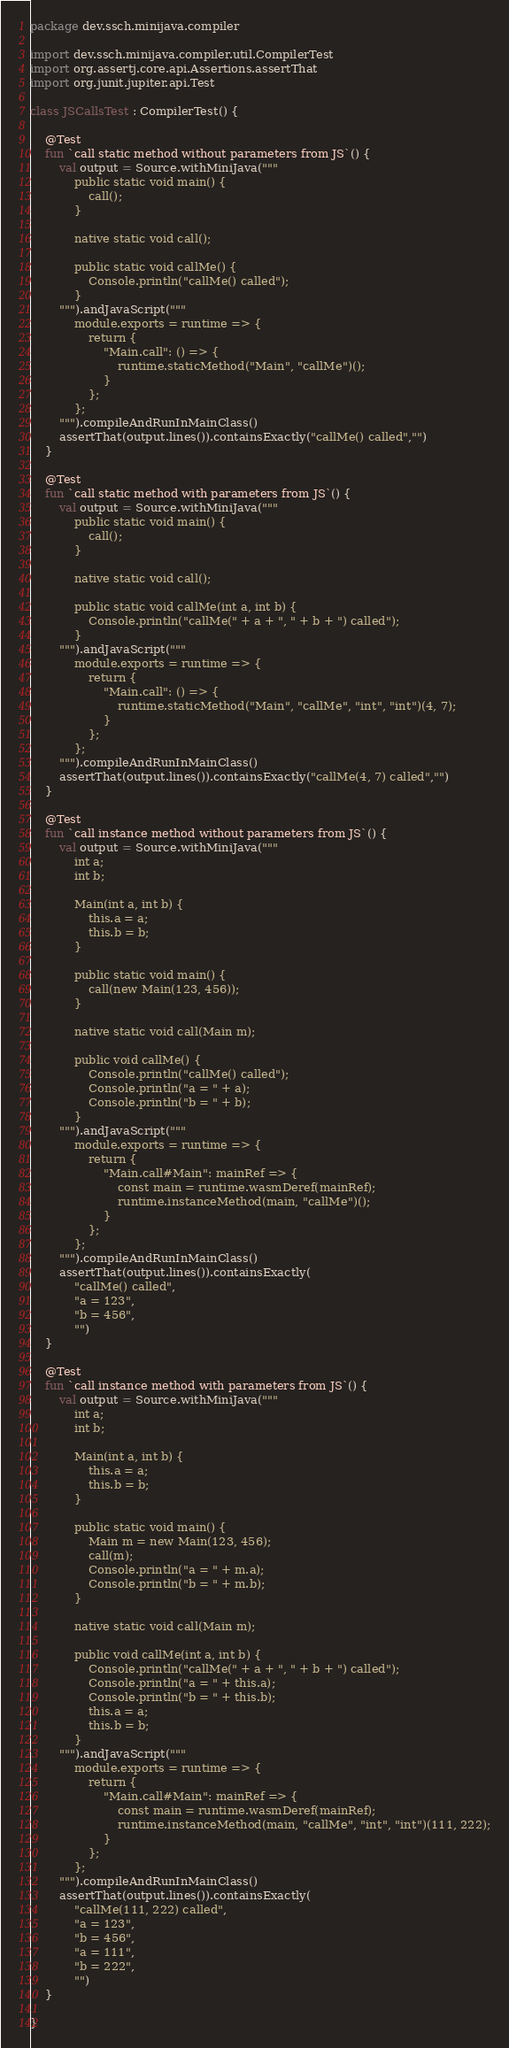<code> <loc_0><loc_0><loc_500><loc_500><_Kotlin_>package dev.ssch.minijava.compiler

import dev.ssch.minijava.compiler.util.CompilerTest
import org.assertj.core.api.Assertions.assertThat
import org.junit.jupiter.api.Test

class JSCallsTest : CompilerTest() {

    @Test
    fun `call static method without parameters from JS`() {
        val output = Source.withMiniJava("""
            public static void main() {
                call();
            }
            
            native static void call();
            
            public static void callMe() {
                Console.println("callMe() called");
            }
        """).andJavaScript("""
            module.exports = runtime => {
                return {
                    "Main.call": () => {
                        runtime.staticMethod("Main", "callMe")();
                    }
                };
            };
        """).compileAndRunInMainClass()
        assertThat(output.lines()).containsExactly("callMe() called","")
    }

    @Test
    fun `call static method with parameters from JS`() {
        val output = Source.withMiniJava("""
            public static void main() {
                call();
            }
            
            native static void call();
            
            public static void callMe(int a, int b) {
                Console.println("callMe(" + a + ", " + b + ") called");
            }
        """).andJavaScript("""
            module.exports = runtime => {
                return {
                    "Main.call": () => {
                        runtime.staticMethod("Main", "callMe", "int", "int")(4, 7);
                    }
                };
            };
        """).compileAndRunInMainClass()
        assertThat(output.lines()).containsExactly("callMe(4, 7) called","")
    }

    @Test
    fun `call instance method without parameters from JS`() {
        val output = Source.withMiniJava("""
            int a;
            int b;
            
            Main(int a, int b) {
                this.a = a;
                this.b = b;
            }
            
            public static void main() {
                call(new Main(123, 456));
            }
            
            native static void call(Main m);
            
            public void callMe() {
                Console.println("callMe() called");
                Console.println("a = " + a);
                Console.println("b = " + b);
            }
        """).andJavaScript("""
            module.exports = runtime => {
                return {
                    "Main.call#Main": mainRef => {
                        const main = runtime.wasmDeref(mainRef);
                        runtime.instanceMethod(main, "callMe")();
                    }
                };
            };
        """).compileAndRunInMainClass()
        assertThat(output.lines()).containsExactly(
            "callMe() called",
            "a = 123",
            "b = 456",
            "")
    }

    @Test
    fun `call instance method with parameters from JS`() {
        val output = Source.withMiniJava("""
            int a;
            int b;
            
            Main(int a, int b) {
                this.a = a;
                this.b = b;
            }
            
            public static void main() {
                Main m = new Main(123, 456);
                call(m);
                Console.println("a = " + m.a);
                Console.println("b = " + m.b);
            }
            
            native static void call(Main m);
            
            public void callMe(int a, int b) {
                Console.println("callMe(" + a + ", " + b + ") called");
                Console.println("a = " + this.a);
                Console.println("b = " + this.b);
                this.a = a;
                this.b = b;
            }
        """).andJavaScript("""
            module.exports = runtime => {
                return {
                    "Main.call#Main": mainRef => {
                        const main = runtime.wasmDeref(mainRef);
                        runtime.instanceMethod(main, "callMe", "int", "int")(111, 222);
                    }
                };
            };
        """).compileAndRunInMainClass()
        assertThat(output.lines()).containsExactly(
            "callMe(111, 222) called",
            "a = 123",
            "b = 456",
            "a = 111",
            "b = 222",
            "")
    }

}</code> 